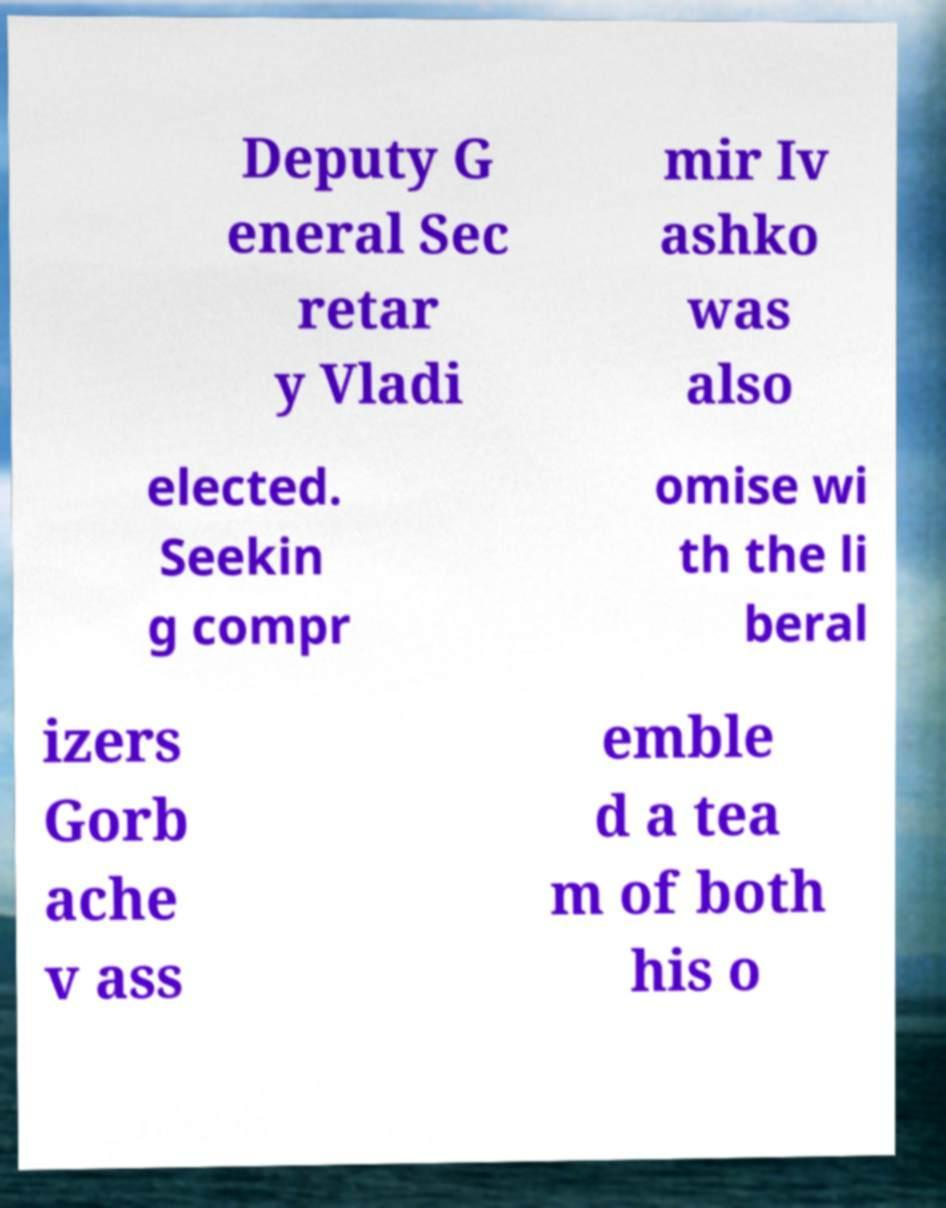Can you read and provide the text displayed in the image?This photo seems to have some interesting text. Can you extract and type it out for me? Deputy G eneral Sec retar y Vladi mir Iv ashko was also elected. Seekin g compr omise wi th the li beral izers Gorb ache v ass emble d a tea m of both his o 